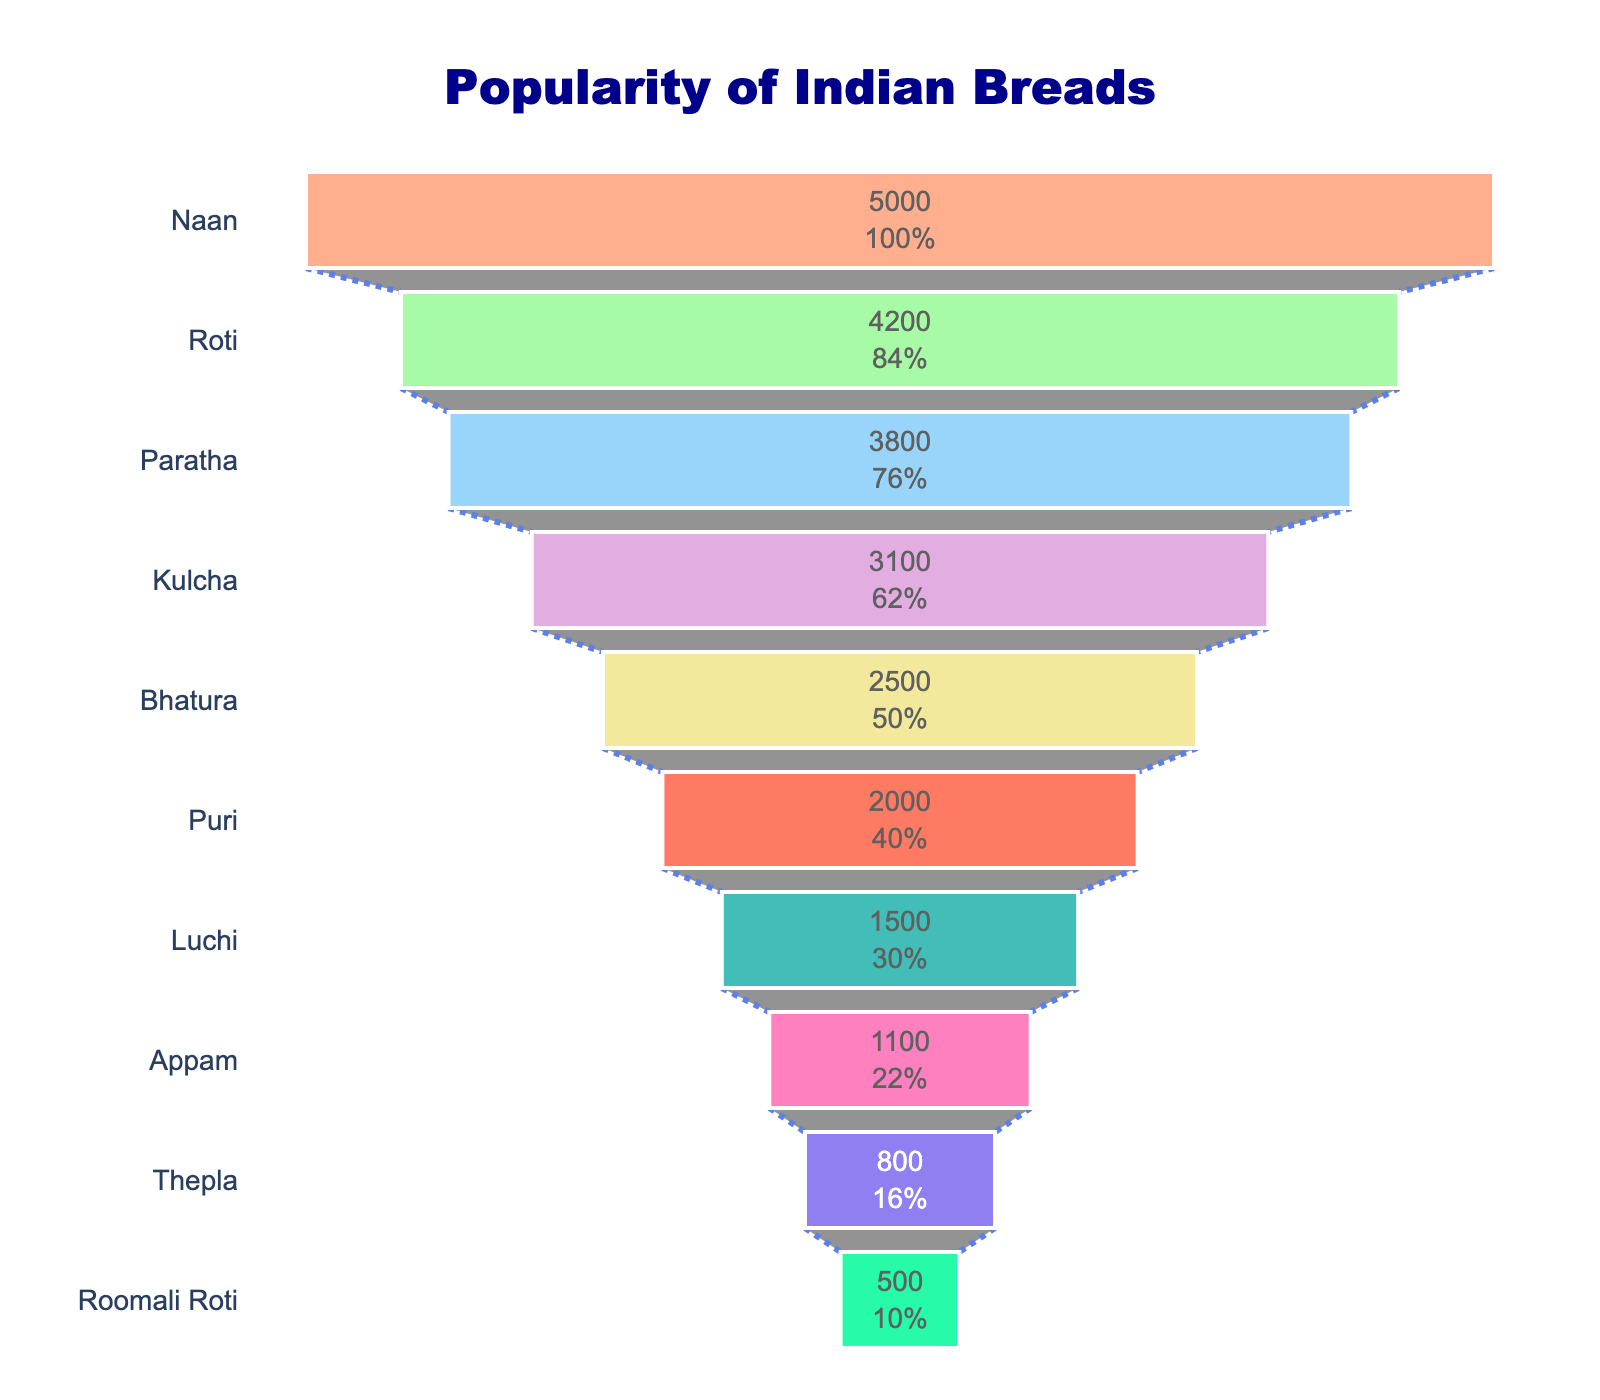Which Indian bread is the most popular? The figure shows the popularity of different Indian breads, with Naan having the highest value at the top of the funnel.
Answer: Naan Which Indian bread is the least popular? The figure shows the popularity of different Indian breads, with Roomali Roti having the lowest value at the bottom of the funnel.
Answer: Roomali Roti What percentage of readers prefer Naan over Roti? The figure displays the popularity and percentage values inside each segment. The exact percentage for Naan and Roti are visible in their respective segments showing their preference relative to their initial population.
Answer: 83.33% How many more readers prefer Paratha over Luchi? To find out, subtract the number of Luchi preferences from the number of Paratha preferences: 3800 - 1500 = 2300.
Answer: 2300 Which Indian bread ranks 4th in popularity? The funnel visually displays each bread's ranking by popularity. Kulcha is the fourth bread listed from top to bottom.
Answer: Kulcha What is the combined popularity of Appam and Thepla? Add the popularity values of Appam (1100) and Thepla (800): 1100 + 800 = 1900.
Answer: 1900 Is Bhatura more popular than Puri? By comparing the positions of Bhatura and Puri in the funnel, Bhatura is higher than Puri, indicating it is more popular.
Answer: Yes What fraction of readers prefer Roomali Roti compared to those who prefer Puri? Roomali Roti has a popularity of 500 and Puri has 2000. To get the fraction, divide 500 by 2000 which equals 0.25.
Answer: 0.25 Which two Indian breads have the closest popularity figures? By examining the values, Appam (1100) and Thepla (800) are more closely spaced compared to the rest. The difference is 1100 - 800 = 300.
Answer: Appam and Thepla How much more popular is Roti compared to Kulcha? Subtract the popularity of Kulcha from Roti: 4200 - 3100 = 1100.
Answer: 1100 